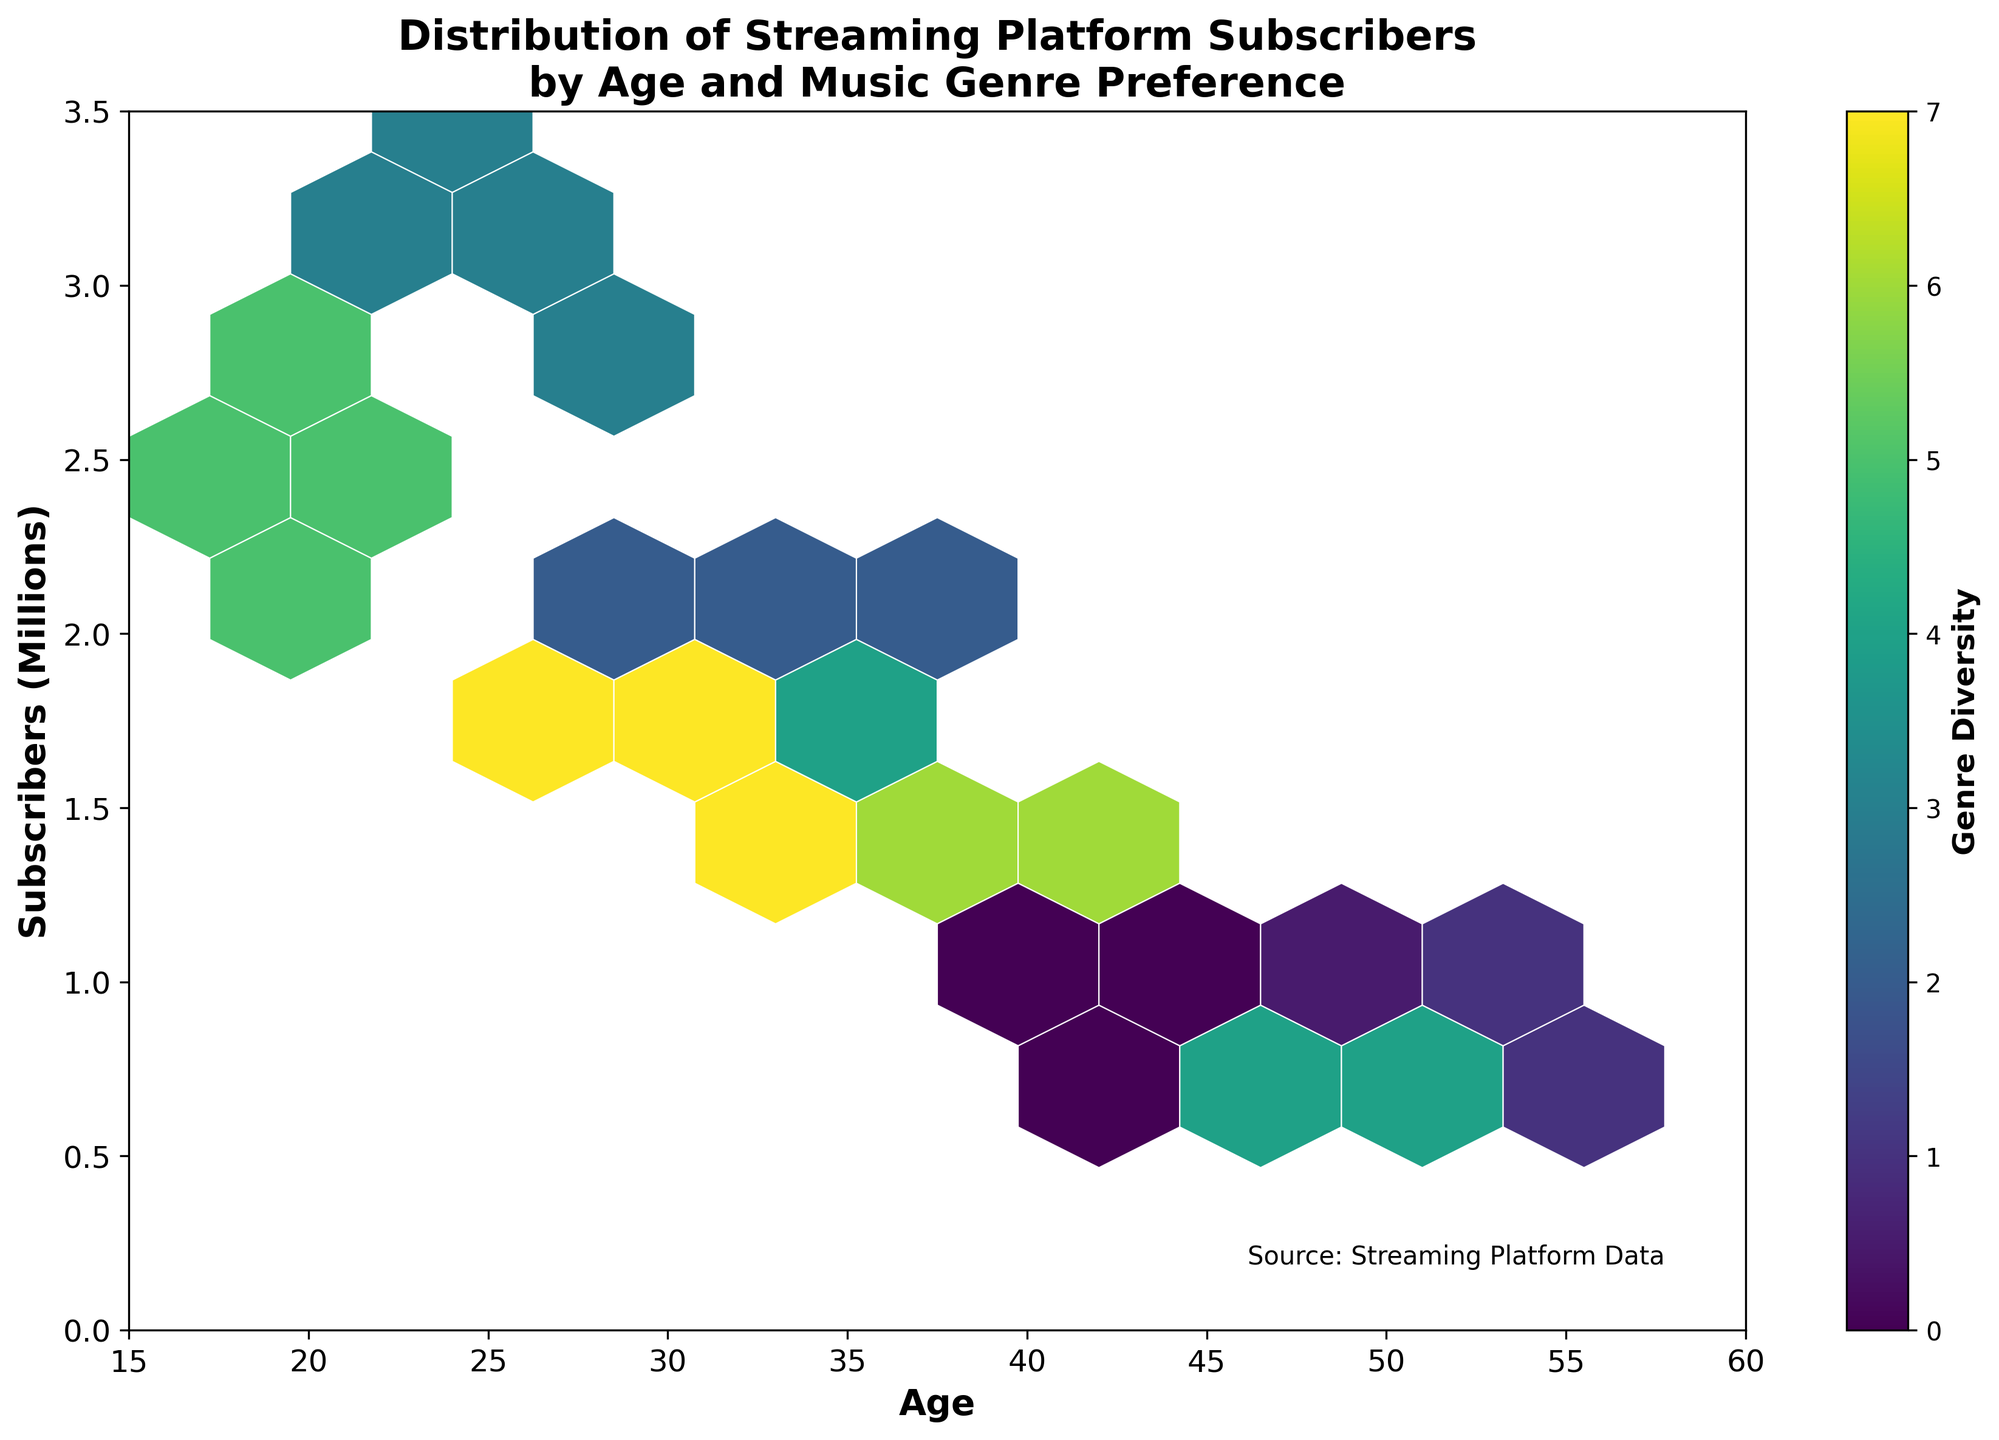What is the title of the chart? The title is typically found at the top of the chart. In this case, it reads "Distribution of Streaming Platform Subscribers by Age and Music Genre Preference".
Answer: Distribution of Streaming Platform Subscribers by Age and Music Genre Preference What is the range of ages displayed on the x-axis? The x-axis label reads "Age", and the ticks show that the ages range from 15 to 60.
Answer: 15 to 60 What does the color represent in the hexbin plot? The color in the hexbin plot represents "Genre Diversity", as indicated by the color bar on the right side of the plot.
Answer: Genre Diversity How many millions of subscribers does the y-axis range from? The y-axis label reads "Subscribers (Millions)" and the ticks show the range from 0 to 3.5 million subscribers.
Answer: 0 to 3.5 Which age group has the highest concentration of subscribers and in what subscriber range? By observing the plot, the age groups around 20 to 30 have the highest density of hexagons, particularly in the 2 to 3 million subscriber range.
Answer: 20 to 30, 2 to 3 million In which age group is the genre diversity the highest? The color bar represents genre diversity, and the brightest or most varied colors show high diversity. Age groups around 20 to 30 display the highest genre diversity.
Answer: 20 to 30 How does the subscriber count trend change with age? The hexbin plot depicts a generally decreasing trend in subscriber counts as age increases, with a noticeable concentration of higher counts among the younger age groups.
Answer: Decreases with age Which age group has the least subscribers, and what is the subscriber count in that range? The hexbin plot shows the least concentration of hexagons in the 50+ age range, specifically around 0 to 1 million subscribers.
Answer: 50+, 0 to 1 million Between which age groups is there a noticeable shift in genre diversity? By observing color changes, the noticeable shift in genre diversity appears between the younger age groups (20-30) and the older groups (40+).
Answer: 20-30 and 40+ What can be inferred about the Music Genre Preference across different age groups from the plot? The plot shows higher genre diversity in younger age groups, suggesting these groups have a more varied music taste, whereas older groups have less genre diversity, implying they prefer fewer genres.
Answer: Younger age groups have higher genre diversity 